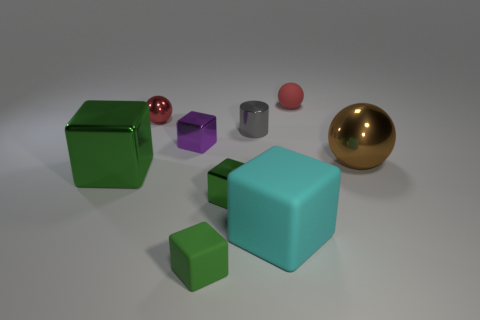Does the small red ball that is left of the large cyan block have the same material as the gray object?
Ensure brevity in your answer.  Yes. Is the number of small things that are in front of the tiny cylinder less than the number of large purple rubber blocks?
Provide a short and direct response. No. What number of rubber things are tiny purple objects or large green cubes?
Give a very brief answer. 0. Do the big metal block and the tiny cylinder have the same color?
Offer a terse response. No. Is there any other thing that has the same color as the big shiny sphere?
Provide a succinct answer. No. Is the shape of the tiny rubber thing that is in front of the red rubber thing the same as the small matte object that is to the right of the small green shiny block?
Provide a short and direct response. No. How many things are either blue spheres or green things that are behind the cyan rubber cube?
Provide a succinct answer. 2. What number of other objects are the same size as the cyan object?
Offer a very short reply. 2. Is the material of the tiny thing left of the small purple object the same as the small ball that is to the right of the cyan rubber object?
Ensure brevity in your answer.  No. How many things are in front of the cyan object?
Provide a succinct answer. 1. 